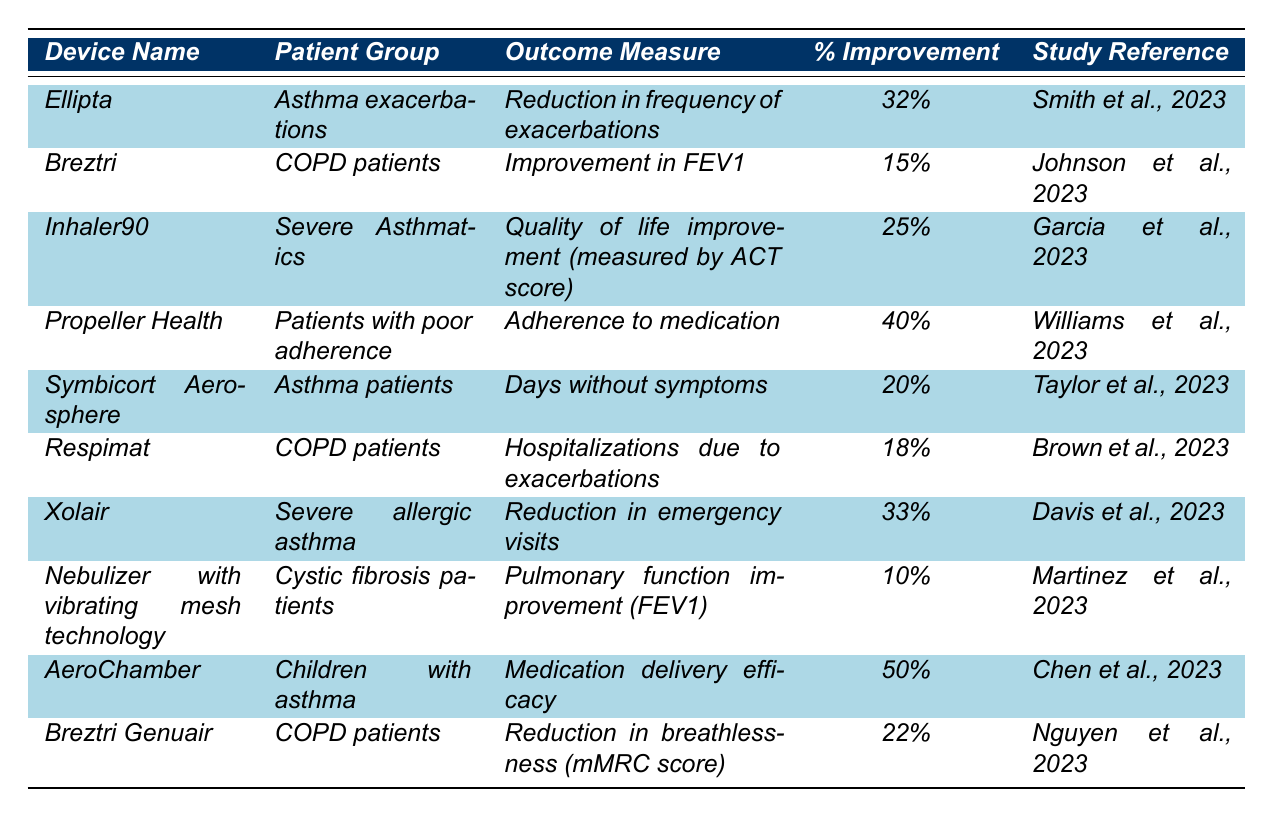What is the percent improvement for the AeroChamber device? The AeroChamber device shows a percent improvement of 50%, which can be found directly in the table under the "% Improvement" column for the corresponding device row.
Answer: 50% Which device had the highest reduction in emergency visits? The data shows that the Xolair device had the highest percent improvement in reducing emergency visits, which is 33%, located in its corresponding row in the table.
Answer: Xolair What is the average percent improvement across all devices for COPD patients? The percent improvements for COPD patients listed in the table are 15% (Breztri), 18% (Respimat), and 22% (Breztri Genuair). The sum of these values is 15 + 18 + 22 = 55, and there are 3 devices, so the average is 55/3 = 18.33%.
Answer: 18.33% Which patient group experienced the greatest improvement in adherence to medication? The Propeller Health device showed a 40% improvement in adherence to medication for patients with poor adherence. This is noted in the outcome measure for that device's row.
Answer: Patients with poor adherence Is there a device listed that showed an improvement of 10% or less? Yes, the "Nebulizer with vibrating mesh technology" device showed only a 10% improvement in pulmonary function (FEV1) for cystic fibrosis patients, which is directly indicated in the table.
Answer: Yes What is the difference in percent improvement between the device with the highest outcome measure and the device with the lowest? The device with the highest percent improvement is AeroChamber at 50%, while the lowest is the Nebulizer with vibrating mesh technology at 10%. The difference is 50 - 10 = 40%.
Answer: 40% Which outcome measure had the second highest improvement overall? The second highest percent improvement is for the device AeroChamber with 50%. The highest is for Propeller Health with 40% related to adherence. By consulting the percent improvements in descending order, we can ascertain this.
Answer: AeroChamber Were there more devices focused on asthma patients or COPD patients? The table includes 4 devices for asthma patients (Ellipta, Inhaler90, Symbicort Aerosphere, and Xolair) and 3 for COPD patients (Breztri, Respimat, and Breztri Genuair). Since 4 is greater than 3, it indicates there are more devices focused on asthma.
Answer: More focused on asthma patients What percentage improvement did Breztri Genuair achieve for COPD patients? Breztri Genuair achieved a percent improvement of 22% in reduction of breathlessness according to the table under the entry corresponding to this device.
Answer: 22% Which study reference corresponds to the device Inhaler90? The study reference for the Inhaler90 device is "Garcia et al., 2023," as stated in the table within the relevant row for this device.
Answer: Garcia et al., 2023 